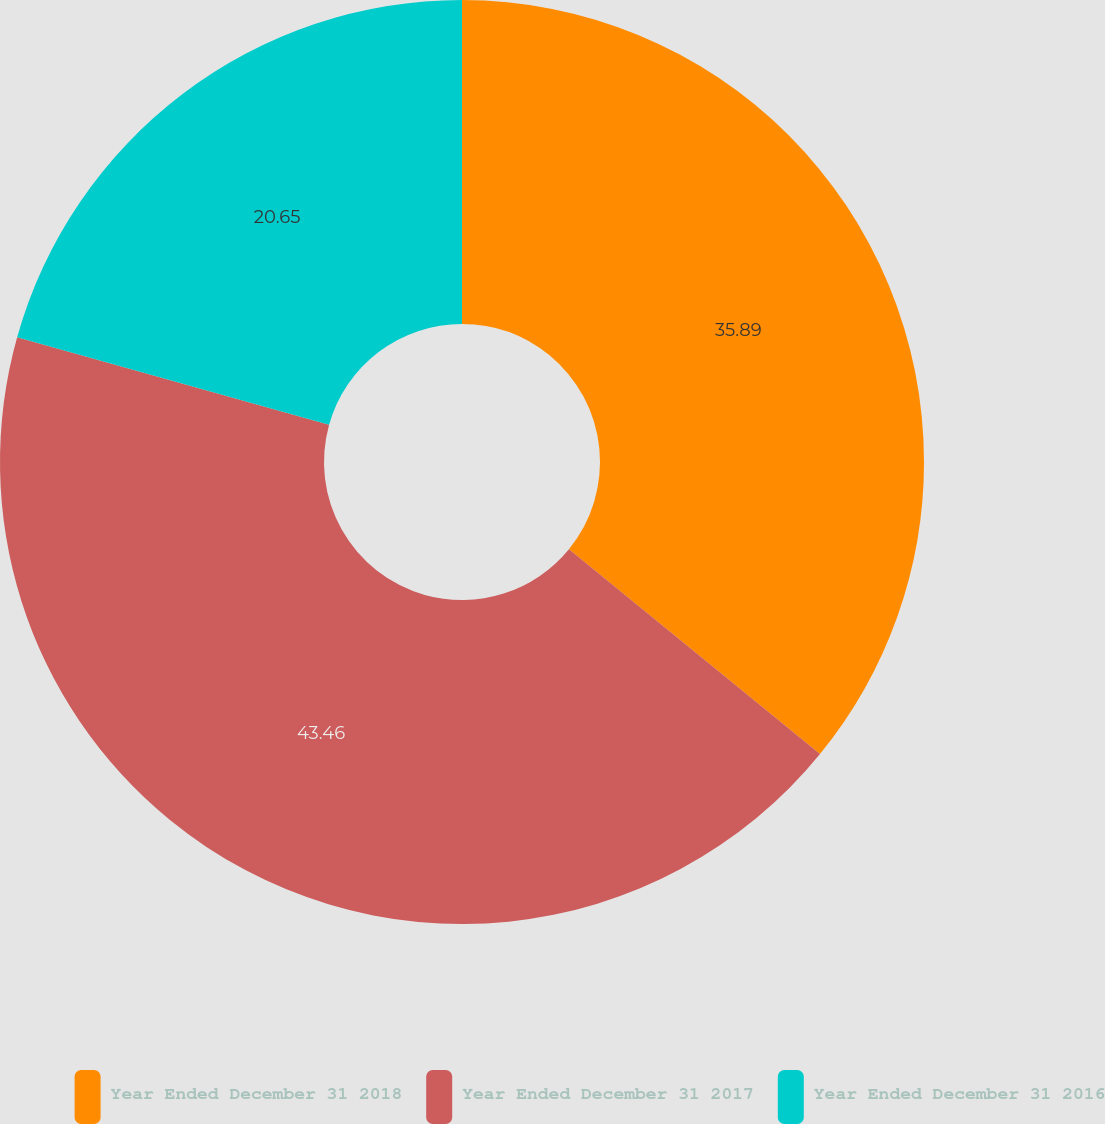Convert chart. <chart><loc_0><loc_0><loc_500><loc_500><pie_chart><fcel>Year Ended December 31 2018<fcel>Year Ended December 31 2017<fcel>Year Ended December 31 2016<nl><fcel>35.89%<fcel>43.46%<fcel>20.65%<nl></chart> 